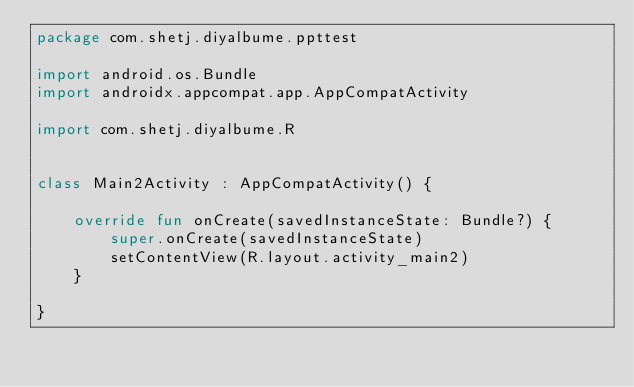<code> <loc_0><loc_0><loc_500><loc_500><_Kotlin_>package com.shetj.diyalbume.ppttest

import android.os.Bundle
import androidx.appcompat.app.AppCompatActivity

import com.shetj.diyalbume.R


class Main2Activity : AppCompatActivity() {

    override fun onCreate(savedInstanceState: Bundle?) {
        super.onCreate(savedInstanceState)
        setContentView(R.layout.activity_main2)
    }

}
</code> 